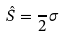<formula> <loc_0><loc_0><loc_500><loc_500>\hat { S } = { \frac { } { 2 } } { \sigma } \,</formula> 